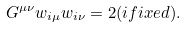Convert formula to latex. <formula><loc_0><loc_0><loc_500><loc_500>G ^ { \mu \nu } w _ { i \mu } w _ { i \nu } = 2 ( i f i x e d ) .</formula> 